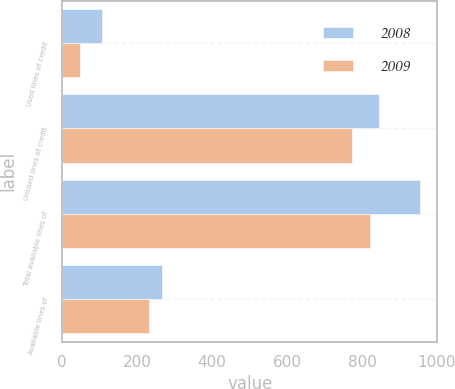<chart> <loc_0><loc_0><loc_500><loc_500><stacked_bar_chart><ecel><fcel>Used lines of credit<fcel>Unused lines of credit<fcel>Total available lines of<fcel>Available lines of<nl><fcel>2008<fcel>107.1<fcel>846.3<fcel>953.4<fcel>267.3<nl><fcel>2009<fcel>46.7<fcel>773.4<fcel>820.1<fcel>231.3<nl></chart> 